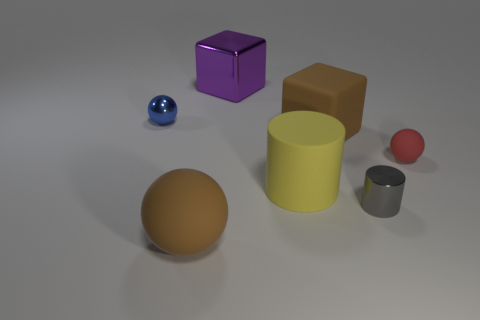What number of gray metal things are in front of the rubber thing to the left of the purple metallic cube?
Give a very brief answer. 0. There is another shiny object that is the same shape as the red thing; what is its color?
Offer a terse response. Blue. Does the purple thing have the same material as the gray cylinder?
Your response must be concise. Yes. How many blocks are either large rubber objects or large gray things?
Keep it short and to the point. 1. What size is the rubber ball that is to the left of the rubber ball on the right side of the object that is behind the blue metallic object?
Provide a short and direct response. Large. The brown thing that is the same shape as the blue object is what size?
Provide a succinct answer. Large. There is a shiny ball; how many red spheres are to the right of it?
Keep it short and to the point. 1. Do the big rubber object that is on the left side of the matte cylinder and the big rubber block have the same color?
Provide a succinct answer. Yes. What number of red objects are either big blocks or small metal balls?
Provide a short and direct response. 0. What color is the small metallic object on the right side of the cube behind the tiny blue shiny thing?
Your answer should be very brief. Gray. 